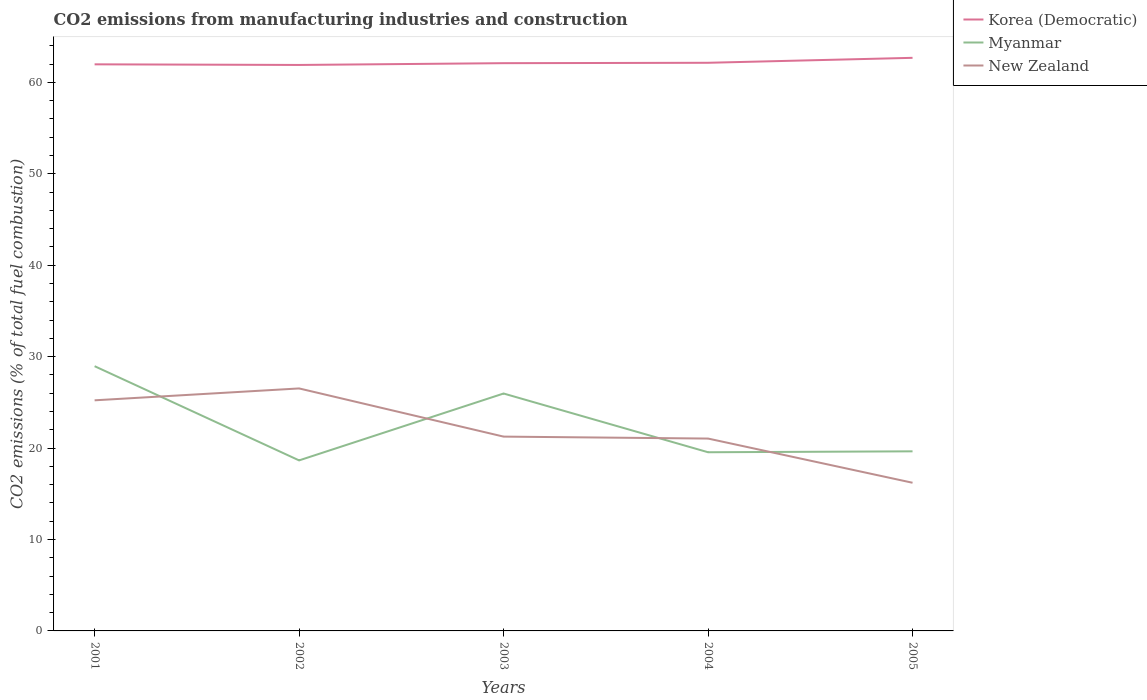How many different coloured lines are there?
Your answer should be very brief. 3. Is the number of lines equal to the number of legend labels?
Ensure brevity in your answer.  Yes. Across all years, what is the maximum amount of CO2 emitted in New Zealand?
Your answer should be compact. 16.2. In which year was the amount of CO2 emitted in Myanmar maximum?
Your response must be concise. 2002. What is the total amount of CO2 emitted in New Zealand in the graph?
Ensure brevity in your answer.  4.18. What is the difference between the highest and the second highest amount of CO2 emitted in Korea (Democratic)?
Keep it short and to the point. 0.78. Is the amount of CO2 emitted in Korea (Democratic) strictly greater than the amount of CO2 emitted in Myanmar over the years?
Provide a succinct answer. No. How many lines are there?
Offer a very short reply. 3. How many years are there in the graph?
Provide a succinct answer. 5. What is the difference between two consecutive major ticks on the Y-axis?
Keep it short and to the point. 10. Does the graph contain any zero values?
Offer a very short reply. No. Does the graph contain grids?
Make the answer very short. No. How many legend labels are there?
Give a very brief answer. 3. How are the legend labels stacked?
Offer a very short reply. Vertical. What is the title of the graph?
Your response must be concise. CO2 emissions from manufacturing industries and construction. What is the label or title of the X-axis?
Your answer should be very brief. Years. What is the label or title of the Y-axis?
Make the answer very short. CO2 emissions (% of total fuel combustion). What is the CO2 emissions (% of total fuel combustion) of Korea (Democratic) in 2001?
Your answer should be very brief. 61.97. What is the CO2 emissions (% of total fuel combustion) of Myanmar in 2001?
Offer a very short reply. 28.95. What is the CO2 emissions (% of total fuel combustion) in New Zealand in 2001?
Offer a very short reply. 25.22. What is the CO2 emissions (% of total fuel combustion) of Korea (Democratic) in 2002?
Offer a very short reply. 61.9. What is the CO2 emissions (% of total fuel combustion) of Myanmar in 2002?
Keep it short and to the point. 18.65. What is the CO2 emissions (% of total fuel combustion) of New Zealand in 2002?
Make the answer very short. 26.52. What is the CO2 emissions (% of total fuel combustion) of Korea (Democratic) in 2003?
Give a very brief answer. 62.09. What is the CO2 emissions (% of total fuel combustion) of Myanmar in 2003?
Give a very brief answer. 25.97. What is the CO2 emissions (% of total fuel combustion) in New Zealand in 2003?
Your response must be concise. 21.25. What is the CO2 emissions (% of total fuel combustion) of Korea (Democratic) in 2004?
Ensure brevity in your answer.  62.14. What is the CO2 emissions (% of total fuel combustion) in Myanmar in 2004?
Ensure brevity in your answer.  19.54. What is the CO2 emissions (% of total fuel combustion) of New Zealand in 2004?
Your response must be concise. 21.04. What is the CO2 emissions (% of total fuel combustion) in Korea (Democratic) in 2005?
Provide a succinct answer. 62.68. What is the CO2 emissions (% of total fuel combustion) of Myanmar in 2005?
Give a very brief answer. 19.64. What is the CO2 emissions (% of total fuel combustion) of New Zealand in 2005?
Ensure brevity in your answer.  16.2. Across all years, what is the maximum CO2 emissions (% of total fuel combustion) in Korea (Democratic)?
Your response must be concise. 62.68. Across all years, what is the maximum CO2 emissions (% of total fuel combustion) of Myanmar?
Offer a very short reply. 28.95. Across all years, what is the maximum CO2 emissions (% of total fuel combustion) in New Zealand?
Make the answer very short. 26.52. Across all years, what is the minimum CO2 emissions (% of total fuel combustion) of Korea (Democratic)?
Make the answer very short. 61.9. Across all years, what is the minimum CO2 emissions (% of total fuel combustion) of Myanmar?
Your response must be concise. 18.65. Across all years, what is the minimum CO2 emissions (% of total fuel combustion) of New Zealand?
Your answer should be very brief. 16.2. What is the total CO2 emissions (% of total fuel combustion) in Korea (Democratic) in the graph?
Offer a very short reply. 310.78. What is the total CO2 emissions (% of total fuel combustion) of Myanmar in the graph?
Your answer should be compact. 112.75. What is the total CO2 emissions (% of total fuel combustion) in New Zealand in the graph?
Your answer should be compact. 110.24. What is the difference between the CO2 emissions (% of total fuel combustion) in Korea (Democratic) in 2001 and that in 2002?
Your response must be concise. 0.07. What is the difference between the CO2 emissions (% of total fuel combustion) in Myanmar in 2001 and that in 2002?
Ensure brevity in your answer.  10.3. What is the difference between the CO2 emissions (% of total fuel combustion) of New Zealand in 2001 and that in 2002?
Provide a short and direct response. -1.3. What is the difference between the CO2 emissions (% of total fuel combustion) in Korea (Democratic) in 2001 and that in 2003?
Your answer should be compact. -0.13. What is the difference between the CO2 emissions (% of total fuel combustion) in Myanmar in 2001 and that in 2003?
Provide a short and direct response. 2.99. What is the difference between the CO2 emissions (% of total fuel combustion) of New Zealand in 2001 and that in 2003?
Make the answer very short. 3.97. What is the difference between the CO2 emissions (% of total fuel combustion) of Korea (Democratic) in 2001 and that in 2004?
Your answer should be very brief. -0.17. What is the difference between the CO2 emissions (% of total fuel combustion) of Myanmar in 2001 and that in 2004?
Keep it short and to the point. 9.41. What is the difference between the CO2 emissions (% of total fuel combustion) of New Zealand in 2001 and that in 2004?
Your answer should be very brief. 4.18. What is the difference between the CO2 emissions (% of total fuel combustion) in Korea (Democratic) in 2001 and that in 2005?
Ensure brevity in your answer.  -0.71. What is the difference between the CO2 emissions (% of total fuel combustion) in Myanmar in 2001 and that in 2005?
Keep it short and to the point. 9.31. What is the difference between the CO2 emissions (% of total fuel combustion) of New Zealand in 2001 and that in 2005?
Offer a very short reply. 9.02. What is the difference between the CO2 emissions (% of total fuel combustion) of Korea (Democratic) in 2002 and that in 2003?
Keep it short and to the point. -0.2. What is the difference between the CO2 emissions (% of total fuel combustion) of Myanmar in 2002 and that in 2003?
Your response must be concise. -7.31. What is the difference between the CO2 emissions (% of total fuel combustion) in New Zealand in 2002 and that in 2003?
Your answer should be compact. 5.27. What is the difference between the CO2 emissions (% of total fuel combustion) in Korea (Democratic) in 2002 and that in 2004?
Offer a very short reply. -0.24. What is the difference between the CO2 emissions (% of total fuel combustion) of Myanmar in 2002 and that in 2004?
Your answer should be compact. -0.89. What is the difference between the CO2 emissions (% of total fuel combustion) in New Zealand in 2002 and that in 2004?
Provide a short and direct response. 5.48. What is the difference between the CO2 emissions (% of total fuel combustion) of Korea (Democratic) in 2002 and that in 2005?
Ensure brevity in your answer.  -0.78. What is the difference between the CO2 emissions (% of total fuel combustion) of Myanmar in 2002 and that in 2005?
Make the answer very short. -0.99. What is the difference between the CO2 emissions (% of total fuel combustion) in New Zealand in 2002 and that in 2005?
Keep it short and to the point. 10.32. What is the difference between the CO2 emissions (% of total fuel combustion) in Korea (Democratic) in 2003 and that in 2004?
Provide a short and direct response. -0.04. What is the difference between the CO2 emissions (% of total fuel combustion) in Myanmar in 2003 and that in 2004?
Your answer should be very brief. 6.42. What is the difference between the CO2 emissions (% of total fuel combustion) in New Zealand in 2003 and that in 2004?
Make the answer very short. 0.21. What is the difference between the CO2 emissions (% of total fuel combustion) in Korea (Democratic) in 2003 and that in 2005?
Provide a succinct answer. -0.58. What is the difference between the CO2 emissions (% of total fuel combustion) of Myanmar in 2003 and that in 2005?
Your answer should be compact. 6.32. What is the difference between the CO2 emissions (% of total fuel combustion) of New Zealand in 2003 and that in 2005?
Keep it short and to the point. 5.05. What is the difference between the CO2 emissions (% of total fuel combustion) in Korea (Democratic) in 2004 and that in 2005?
Your answer should be very brief. -0.54. What is the difference between the CO2 emissions (% of total fuel combustion) in Myanmar in 2004 and that in 2005?
Your answer should be very brief. -0.1. What is the difference between the CO2 emissions (% of total fuel combustion) in New Zealand in 2004 and that in 2005?
Your answer should be compact. 4.83. What is the difference between the CO2 emissions (% of total fuel combustion) in Korea (Democratic) in 2001 and the CO2 emissions (% of total fuel combustion) in Myanmar in 2002?
Ensure brevity in your answer.  43.32. What is the difference between the CO2 emissions (% of total fuel combustion) of Korea (Democratic) in 2001 and the CO2 emissions (% of total fuel combustion) of New Zealand in 2002?
Ensure brevity in your answer.  35.45. What is the difference between the CO2 emissions (% of total fuel combustion) in Myanmar in 2001 and the CO2 emissions (% of total fuel combustion) in New Zealand in 2002?
Offer a very short reply. 2.43. What is the difference between the CO2 emissions (% of total fuel combustion) in Korea (Democratic) in 2001 and the CO2 emissions (% of total fuel combustion) in Myanmar in 2003?
Provide a short and direct response. 36. What is the difference between the CO2 emissions (% of total fuel combustion) in Korea (Democratic) in 2001 and the CO2 emissions (% of total fuel combustion) in New Zealand in 2003?
Give a very brief answer. 40.72. What is the difference between the CO2 emissions (% of total fuel combustion) of Myanmar in 2001 and the CO2 emissions (% of total fuel combustion) of New Zealand in 2003?
Your answer should be compact. 7.7. What is the difference between the CO2 emissions (% of total fuel combustion) of Korea (Democratic) in 2001 and the CO2 emissions (% of total fuel combustion) of Myanmar in 2004?
Make the answer very short. 42.43. What is the difference between the CO2 emissions (% of total fuel combustion) in Korea (Democratic) in 2001 and the CO2 emissions (% of total fuel combustion) in New Zealand in 2004?
Your response must be concise. 40.93. What is the difference between the CO2 emissions (% of total fuel combustion) in Myanmar in 2001 and the CO2 emissions (% of total fuel combustion) in New Zealand in 2004?
Make the answer very short. 7.92. What is the difference between the CO2 emissions (% of total fuel combustion) of Korea (Democratic) in 2001 and the CO2 emissions (% of total fuel combustion) of Myanmar in 2005?
Provide a succinct answer. 42.33. What is the difference between the CO2 emissions (% of total fuel combustion) of Korea (Democratic) in 2001 and the CO2 emissions (% of total fuel combustion) of New Zealand in 2005?
Offer a terse response. 45.76. What is the difference between the CO2 emissions (% of total fuel combustion) in Myanmar in 2001 and the CO2 emissions (% of total fuel combustion) in New Zealand in 2005?
Keep it short and to the point. 12.75. What is the difference between the CO2 emissions (% of total fuel combustion) of Korea (Democratic) in 2002 and the CO2 emissions (% of total fuel combustion) of Myanmar in 2003?
Your response must be concise. 35.93. What is the difference between the CO2 emissions (% of total fuel combustion) of Korea (Democratic) in 2002 and the CO2 emissions (% of total fuel combustion) of New Zealand in 2003?
Provide a succinct answer. 40.65. What is the difference between the CO2 emissions (% of total fuel combustion) in Myanmar in 2002 and the CO2 emissions (% of total fuel combustion) in New Zealand in 2003?
Your answer should be compact. -2.6. What is the difference between the CO2 emissions (% of total fuel combustion) of Korea (Democratic) in 2002 and the CO2 emissions (% of total fuel combustion) of Myanmar in 2004?
Ensure brevity in your answer.  42.36. What is the difference between the CO2 emissions (% of total fuel combustion) in Korea (Democratic) in 2002 and the CO2 emissions (% of total fuel combustion) in New Zealand in 2004?
Give a very brief answer. 40.86. What is the difference between the CO2 emissions (% of total fuel combustion) in Myanmar in 2002 and the CO2 emissions (% of total fuel combustion) in New Zealand in 2004?
Give a very brief answer. -2.39. What is the difference between the CO2 emissions (% of total fuel combustion) of Korea (Democratic) in 2002 and the CO2 emissions (% of total fuel combustion) of Myanmar in 2005?
Provide a short and direct response. 42.26. What is the difference between the CO2 emissions (% of total fuel combustion) in Korea (Democratic) in 2002 and the CO2 emissions (% of total fuel combustion) in New Zealand in 2005?
Provide a short and direct response. 45.7. What is the difference between the CO2 emissions (% of total fuel combustion) in Myanmar in 2002 and the CO2 emissions (% of total fuel combustion) in New Zealand in 2005?
Offer a terse response. 2.45. What is the difference between the CO2 emissions (% of total fuel combustion) of Korea (Democratic) in 2003 and the CO2 emissions (% of total fuel combustion) of Myanmar in 2004?
Keep it short and to the point. 42.55. What is the difference between the CO2 emissions (% of total fuel combustion) of Korea (Democratic) in 2003 and the CO2 emissions (% of total fuel combustion) of New Zealand in 2004?
Make the answer very short. 41.06. What is the difference between the CO2 emissions (% of total fuel combustion) of Myanmar in 2003 and the CO2 emissions (% of total fuel combustion) of New Zealand in 2004?
Make the answer very short. 4.93. What is the difference between the CO2 emissions (% of total fuel combustion) of Korea (Democratic) in 2003 and the CO2 emissions (% of total fuel combustion) of Myanmar in 2005?
Make the answer very short. 42.45. What is the difference between the CO2 emissions (% of total fuel combustion) in Korea (Democratic) in 2003 and the CO2 emissions (% of total fuel combustion) in New Zealand in 2005?
Make the answer very short. 45.89. What is the difference between the CO2 emissions (% of total fuel combustion) in Myanmar in 2003 and the CO2 emissions (% of total fuel combustion) in New Zealand in 2005?
Your answer should be very brief. 9.76. What is the difference between the CO2 emissions (% of total fuel combustion) of Korea (Democratic) in 2004 and the CO2 emissions (% of total fuel combustion) of Myanmar in 2005?
Offer a very short reply. 42.5. What is the difference between the CO2 emissions (% of total fuel combustion) in Korea (Democratic) in 2004 and the CO2 emissions (% of total fuel combustion) in New Zealand in 2005?
Provide a succinct answer. 45.93. What is the difference between the CO2 emissions (% of total fuel combustion) of Myanmar in 2004 and the CO2 emissions (% of total fuel combustion) of New Zealand in 2005?
Provide a succinct answer. 3.34. What is the average CO2 emissions (% of total fuel combustion) of Korea (Democratic) per year?
Your answer should be compact. 62.16. What is the average CO2 emissions (% of total fuel combustion) in Myanmar per year?
Give a very brief answer. 22.55. What is the average CO2 emissions (% of total fuel combustion) of New Zealand per year?
Provide a short and direct response. 22.05. In the year 2001, what is the difference between the CO2 emissions (% of total fuel combustion) of Korea (Democratic) and CO2 emissions (% of total fuel combustion) of Myanmar?
Ensure brevity in your answer.  33.01. In the year 2001, what is the difference between the CO2 emissions (% of total fuel combustion) in Korea (Democratic) and CO2 emissions (% of total fuel combustion) in New Zealand?
Make the answer very short. 36.75. In the year 2001, what is the difference between the CO2 emissions (% of total fuel combustion) in Myanmar and CO2 emissions (% of total fuel combustion) in New Zealand?
Provide a short and direct response. 3.73. In the year 2002, what is the difference between the CO2 emissions (% of total fuel combustion) of Korea (Democratic) and CO2 emissions (% of total fuel combustion) of Myanmar?
Your answer should be compact. 43.25. In the year 2002, what is the difference between the CO2 emissions (% of total fuel combustion) in Korea (Democratic) and CO2 emissions (% of total fuel combustion) in New Zealand?
Offer a terse response. 35.38. In the year 2002, what is the difference between the CO2 emissions (% of total fuel combustion) of Myanmar and CO2 emissions (% of total fuel combustion) of New Zealand?
Your response must be concise. -7.87. In the year 2003, what is the difference between the CO2 emissions (% of total fuel combustion) in Korea (Democratic) and CO2 emissions (% of total fuel combustion) in Myanmar?
Make the answer very short. 36.13. In the year 2003, what is the difference between the CO2 emissions (% of total fuel combustion) of Korea (Democratic) and CO2 emissions (% of total fuel combustion) of New Zealand?
Offer a very short reply. 40.84. In the year 2003, what is the difference between the CO2 emissions (% of total fuel combustion) in Myanmar and CO2 emissions (% of total fuel combustion) in New Zealand?
Give a very brief answer. 4.71. In the year 2004, what is the difference between the CO2 emissions (% of total fuel combustion) of Korea (Democratic) and CO2 emissions (% of total fuel combustion) of Myanmar?
Ensure brevity in your answer.  42.6. In the year 2004, what is the difference between the CO2 emissions (% of total fuel combustion) in Korea (Democratic) and CO2 emissions (% of total fuel combustion) in New Zealand?
Your answer should be very brief. 41.1. In the year 2004, what is the difference between the CO2 emissions (% of total fuel combustion) of Myanmar and CO2 emissions (% of total fuel combustion) of New Zealand?
Provide a short and direct response. -1.5. In the year 2005, what is the difference between the CO2 emissions (% of total fuel combustion) in Korea (Democratic) and CO2 emissions (% of total fuel combustion) in Myanmar?
Ensure brevity in your answer.  43.04. In the year 2005, what is the difference between the CO2 emissions (% of total fuel combustion) in Korea (Democratic) and CO2 emissions (% of total fuel combustion) in New Zealand?
Offer a terse response. 46.48. In the year 2005, what is the difference between the CO2 emissions (% of total fuel combustion) in Myanmar and CO2 emissions (% of total fuel combustion) in New Zealand?
Your answer should be compact. 3.44. What is the ratio of the CO2 emissions (% of total fuel combustion) in Korea (Democratic) in 2001 to that in 2002?
Provide a short and direct response. 1. What is the ratio of the CO2 emissions (% of total fuel combustion) in Myanmar in 2001 to that in 2002?
Provide a succinct answer. 1.55. What is the ratio of the CO2 emissions (% of total fuel combustion) of New Zealand in 2001 to that in 2002?
Your answer should be compact. 0.95. What is the ratio of the CO2 emissions (% of total fuel combustion) of Myanmar in 2001 to that in 2003?
Provide a succinct answer. 1.12. What is the ratio of the CO2 emissions (% of total fuel combustion) in New Zealand in 2001 to that in 2003?
Your response must be concise. 1.19. What is the ratio of the CO2 emissions (% of total fuel combustion) in Korea (Democratic) in 2001 to that in 2004?
Offer a terse response. 1. What is the ratio of the CO2 emissions (% of total fuel combustion) of Myanmar in 2001 to that in 2004?
Ensure brevity in your answer.  1.48. What is the ratio of the CO2 emissions (% of total fuel combustion) of New Zealand in 2001 to that in 2004?
Your answer should be compact. 1.2. What is the ratio of the CO2 emissions (% of total fuel combustion) in Korea (Democratic) in 2001 to that in 2005?
Give a very brief answer. 0.99. What is the ratio of the CO2 emissions (% of total fuel combustion) of Myanmar in 2001 to that in 2005?
Offer a terse response. 1.47. What is the ratio of the CO2 emissions (% of total fuel combustion) in New Zealand in 2001 to that in 2005?
Your response must be concise. 1.56. What is the ratio of the CO2 emissions (% of total fuel combustion) in Korea (Democratic) in 2002 to that in 2003?
Keep it short and to the point. 1. What is the ratio of the CO2 emissions (% of total fuel combustion) in Myanmar in 2002 to that in 2003?
Keep it short and to the point. 0.72. What is the ratio of the CO2 emissions (% of total fuel combustion) in New Zealand in 2002 to that in 2003?
Give a very brief answer. 1.25. What is the ratio of the CO2 emissions (% of total fuel combustion) in Myanmar in 2002 to that in 2004?
Your answer should be very brief. 0.95. What is the ratio of the CO2 emissions (% of total fuel combustion) of New Zealand in 2002 to that in 2004?
Offer a terse response. 1.26. What is the ratio of the CO2 emissions (% of total fuel combustion) in Korea (Democratic) in 2002 to that in 2005?
Offer a terse response. 0.99. What is the ratio of the CO2 emissions (% of total fuel combustion) of Myanmar in 2002 to that in 2005?
Make the answer very short. 0.95. What is the ratio of the CO2 emissions (% of total fuel combustion) in New Zealand in 2002 to that in 2005?
Ensure brevity in your answer.  1.64. What is the ratio of the CO2 emissions (% of total fuel combustion) in Korea (Democratic) in 2003 to that in 2004?
Ensure brevity in your answer.  1. What is the ratio of the CO2 emissions (% of total fuel combustion) in Myanmar in 2003 to that in 2004?
Provide a succinct answer. 1.33. What is the ratio of the CO2 emissions (% of total fuel combustion) of New Zealand in 2003 to that in 2004?
Provide a short and direct response. 1.01. What is the ratio of the CO2 emissions (% of total fuel combustion) in Korea (Democratic) in 2003 to that in 2005?
Give a very brief answer. 0.99. What is the ratio of the CO2 emissions (% of total fuel combustion) in Myanmar in 2003 to that in 2005?
Make the answer very short. 1.32. What is the ratio of the CO2 emissions (% of total fuel combustion) in New Zealand in 2003 to that in 2005?
Offer a very short reply. 1.31. What is the ratio of the CO2 emissions (% of total fuel combustion) in Myanmar in 2004 to that in 2005?
Make the answer very short. 0.99. What is the ratio of the CO2 emissions (% of total fuel combustion) in New Zealand in 2004 to that in 2005?
Keep it short and to the point. 1.3. What is the difference between the highest and the second highest CO2 emissions (% of total fuel combustion) in Korea (Democratic)?
Keep it short and to the point. 0.54. What is the difference between the highest and the second highest CO2 emissions (% of total fuel combustion) of Myanmar?
Your answer should be compact. 2.99. What is the difference between the highest and the second highest CO2 emissions (% of total fuel combustion) in New Zealand?
Your response must be concise. 1.3. What is the difference between the highest and the lowest CO2 emissions (% of total fuel combustion) of Korea (Democratic)?
Offer a very short reply. 0.78. What is the difference between the highest and the lowest CO2 emissions (% of total fuel combustion) in Myanmar?
Your answer should be compact. 10.3. What is the difference between the highest and the lowest CO2 emissions (% of total fuel combustion) of New Zealand?
Make the answer very short. 10.32. 